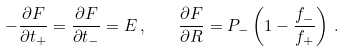<formula> <loc_0><loc_0><loc_500><loc_500>- \frac { \partial F } { \partial t _ { + } } = \frac { \partial F } { \partial t _ { - } } = E \, , \quad \frac { \partial F } { \partial R } = P _ { - } \left ( 1 - \frac { f _ { - } } { f _ { + } } \right ) \, .</formula> 